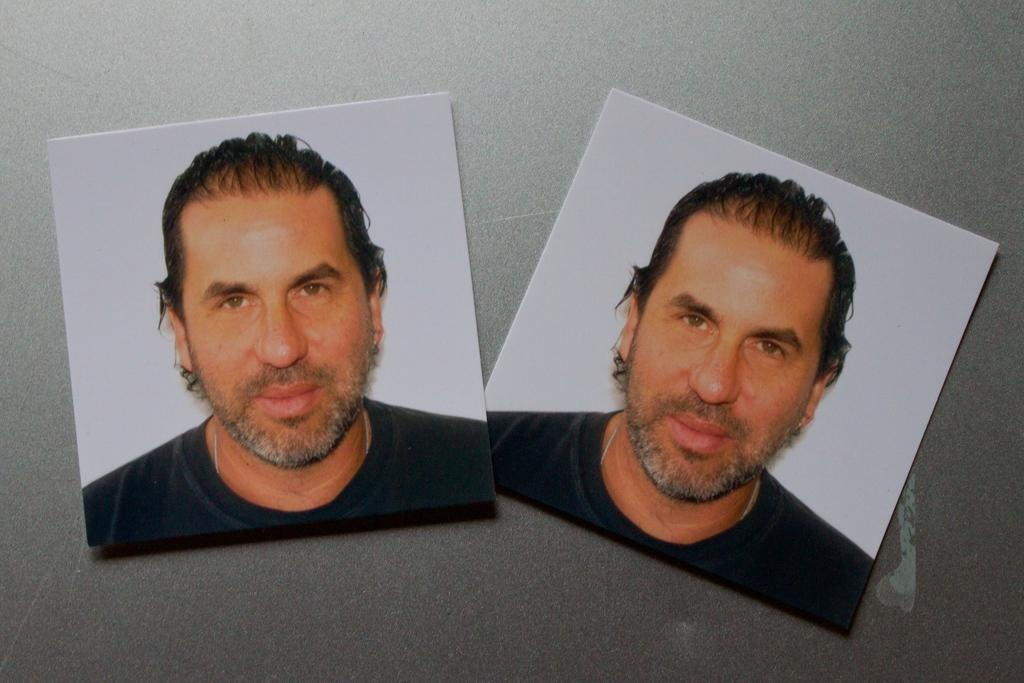What is present on the table in the image? There are photographs of a person on a table. What is the facial expression of the person in the photographs? The person in the photographs is smiling. How many hands are visible in the photographs on the table? There is no mention of hands in the image, as it only features photographs of a person. 